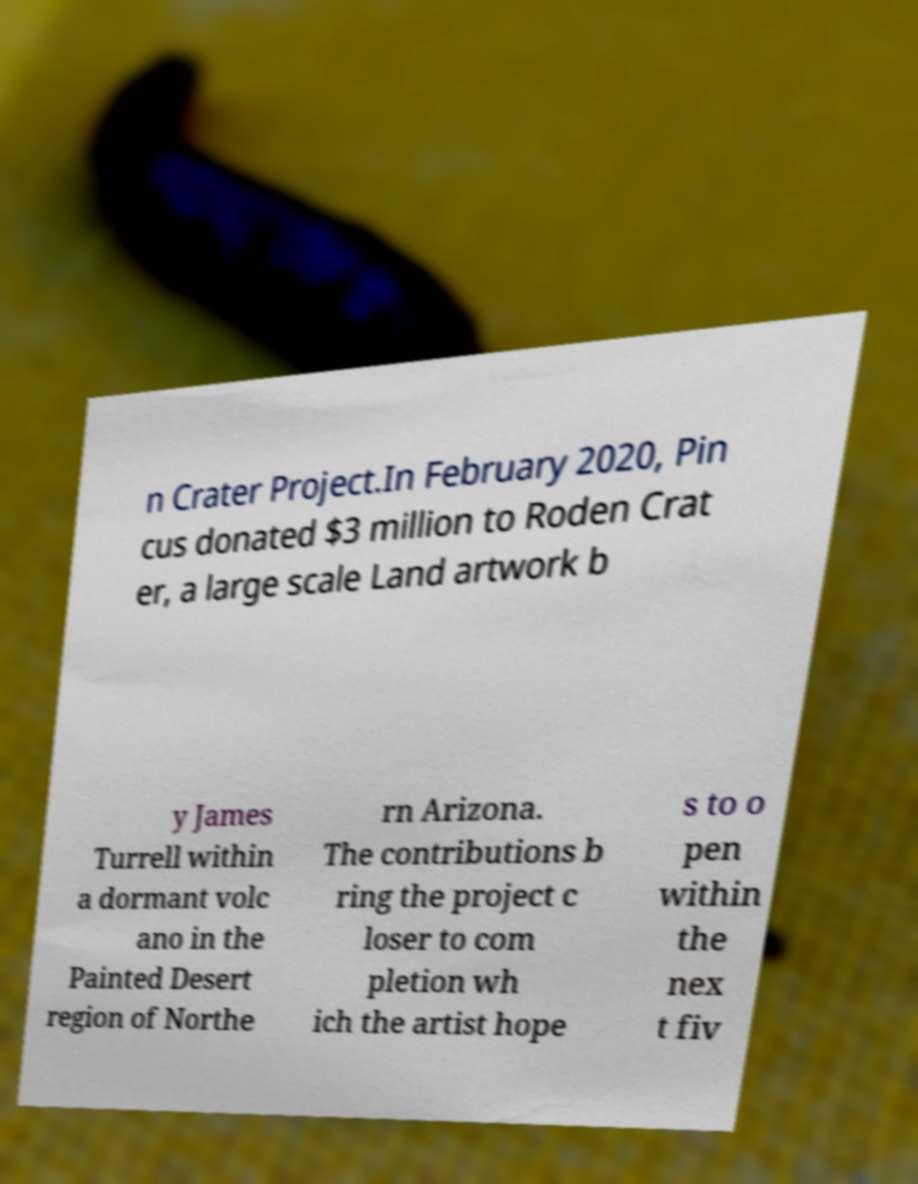Could you extract and type out the text from this image? n Crater Project.In February 2020, Pin cus donated $3 million to Roden Crat er, a large scale Land artwork b y James Turrell within a dormant volc ano in the Painted Desert region of Northe rn Arizona. The contributions b ring the project c loser to com pletion wh ich the artist hope s to o pen within the nex t fiv 